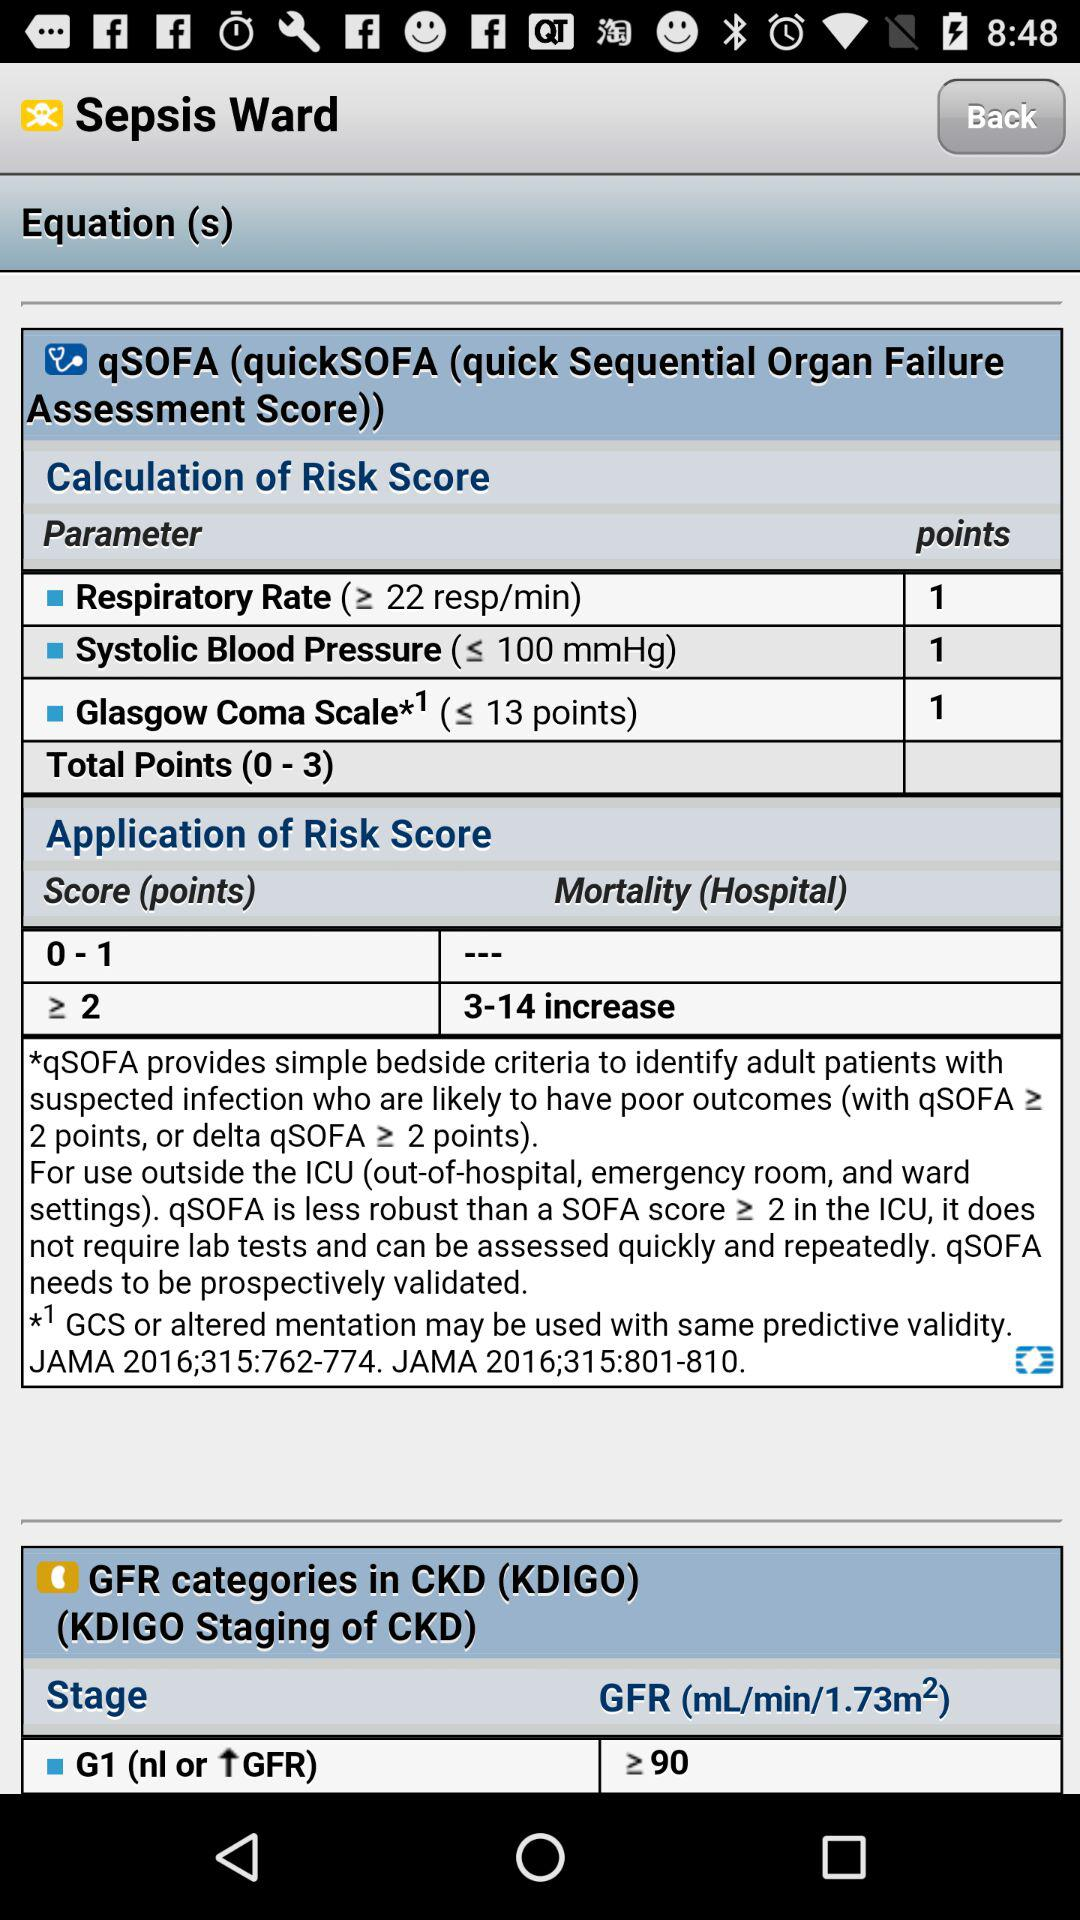What are the parameters for calculating the risk score? The parameters are Respiratory Rate (≥ 22 resp/min), Systolic Blood Pressure (≤ 100 mmHg) and Glasgow Coma Scale*1 (≤ 13 points). 